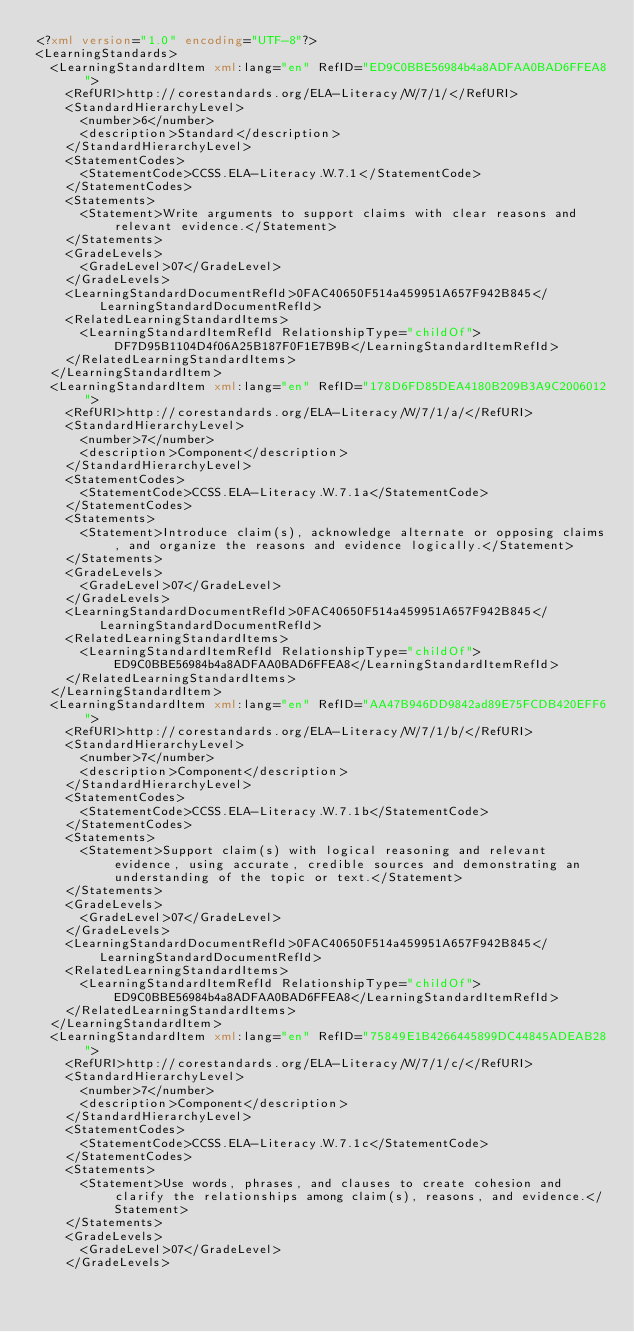<code> <loc_0><loc_0><loc_500><loc_500><_XML_><?xml version="1.0" encoding="UTF-8"?>
<LearningStandards>
  <LearningStandardItem xml:lang="en" RefID="ED9C0BBE56984b4a8ADFAA0BAD6FFEA8">
    <RefURI>http://corestandards.org/ELA-Literacy/W/7/1/</RefURI>
    <StandardHierarchyLevel>
      <number>6</number>
      <description>Standard</description>
    </StandardHierarchyLevel>
    <StatementCodes>
      <StatementCode>CCSS.ELA-Literacy.W.7.1</StatementCode>
    </StatementCodes>
    <Statements>
      <Statement>Write arguments to support claims with clear reasons and relevant evidence.</Statement>
    </Statements>
    <GradeLevels>
      <GradeLevel>07</GradeLevel>
    </GradeLevels>
    <LearningStandardDocumentRefId>0FAC40650F514a459951A657F942B845</LearningStandardDocumentRefId>
    <RelatedLearningStandardItems>
      <LearningStandardItemRefId RelationshipType="childOf">DF7D95B1104D4f06A25B187F0F1E7B9B</LearningStandardItemRefId>
    </RelatedLearningStandardItems>
  </LearningStandardItem>
  <LearningStandardItem xml:lang="en" RefID="178D6FD85DEA4180B209B3A9C2006012">
    <RefURI>http://corestandards.org/ELA-Literacy/W/7/1/a/</RefURI>
    <StandardHierarchyLevel>
      <number>7</number>
      <description>Component</description>
    </StandardHierarchyLevel>
    <StatementCodes>
      <StatementCode>CCSS.ELA-Literacy.W.7.1a</StatementCode>
    </StatementCodes>
    <Statements>
      <Statement>Introduce claim(s), acknowledge alternate or opposing claims, and organize the reasons and evidence logically.</Statement>
    </Statements>
    <GradeLevels>
      <GradeLevel>07</GradeLevel>
    </GradeLevels>
    <LearningStandardDocumentRefId>0FAC40650F514a459951A657F942B845</LearningStandardDocumentRefId>
    <RelatedLearningStandardItems>
      <LearningStandardItemRefId RelationshipType="childOf">ED9C0BBE56984b4a8ADFAA0BAD6FFEA8</LearningStandardItemRefId>
    </RelatedLearningStandardItems>
  </LearningStandardItem>
  <LearningStandardItem xml:lang="en" RefID="AA47B946DD9842ad89E75FCDB420EFF6">
    <RefURI>http://corestandards.org/ELA-Literacy/W/7/1/b/</RefURI>
    <StandardHierarchyLevel>
      <number>7</number>
      <description>Component</description>
    </StandardHierarchyLevel>
    <StatementCodes>
      <StatementCode>CCSS.ELA-Literacy.W.7.1b</StatementCode>
    </StatementCodes>
    <Statements>
      <Statement>Support claim(s) with logical reasoning and relevant evidence, using accurate, credible sources and demonstrating an understanding of the topic or text.</Statement>
    </Statements>
    <GradeLevels>
      <GradeLevel>07</GradeLevel>
    </GradeLevels>
    <LearningStandardDocumentRefId>0FAC40650F514a459951A657F942B845</LearningStandardDocumentRefId>
    <RelatedLearningStandardItems>
      <LearningStandardItemRefId RelationshipType="childOf">ED9C0BBE56984b4a8ADFAA0BAD6FFEA8</LearningStandardItemRefId>
    </RelatedLearningStandardItems>
  </LearningStandardItem>
  <LearningStandardItem xml:lang="en" RefID="75849E1B4266445899DC44845ADEAB28">
    <RefURI>http://corestandards.org/ELA-Literacy/W/7/1/c/</RefURI>
    <StandardHierarchyLevel>
      <number>7</number>
      <description>Component</description>
    </StandardHierarchyLevel>
    <StatementCodes>
      <StatementCode>CCSS.ELA-Literacy.W.7.1c</StatementCode>
    </StatementCodes>
    <Statements>
      <Statement>Use words, phrases, and clauses to create cohesion and clarify the relationships among claim(s), reasons, and evidence.</Statement>
    </Statements>
    <GradeLevels>
      <GradeLevel>07</GradeLevel>
    </GradeLevels></code> 